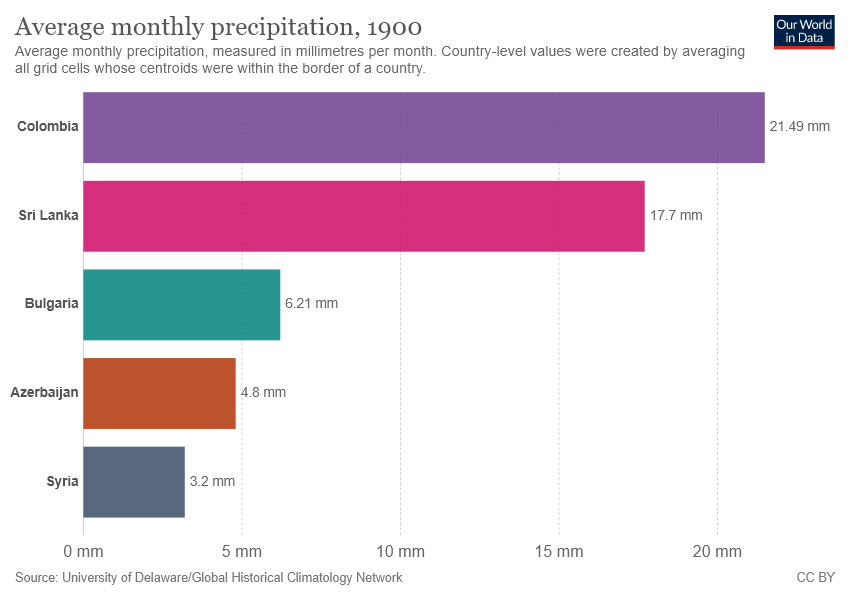Highlight a few significant elements in this photo. The average monthly precipitation in Colombia and Bulgaria is 0.277... Colombia is the number one country/region in the chart. 